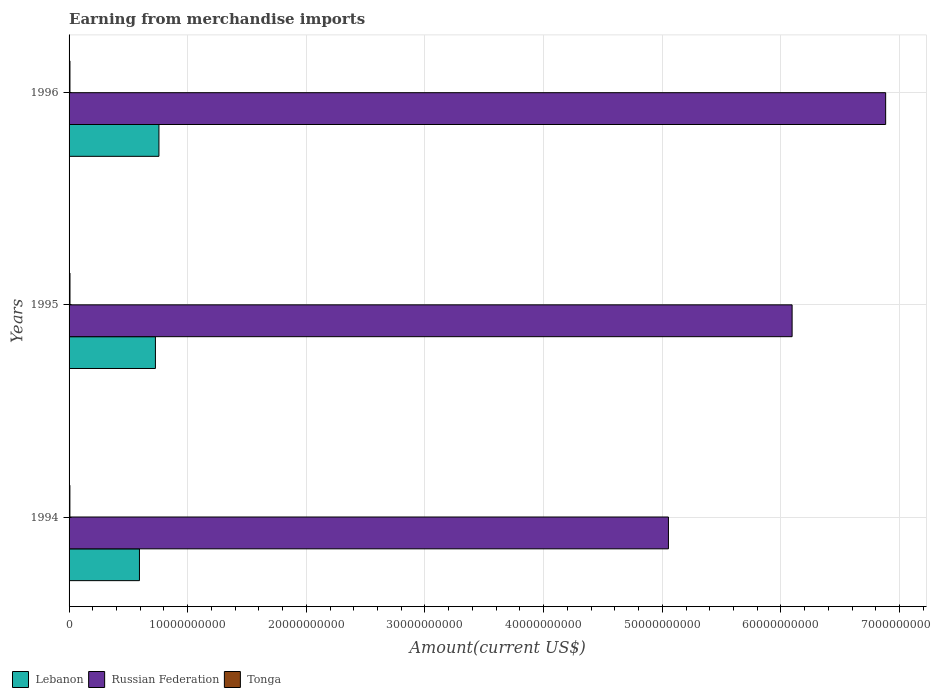How many different coloured bars are there?
Offer a very short reply. 3. Are the number of bars per tick equal to the number of legend labels?
Give a very brief answer. Yes. Are the number of bars on each tick of the Y-axis equal?
Provide a succinct answer. Yes. How many bars are there on the 3rd tick from the top?
Offer a terse response. 3. In how many cases, is the number of bars for a given year not equal to the number of legend labels?
Offer a terse response. 0. What is the amount earned from merchandise imports in Lebanon in 1995?
Offer a very short reply. 7.28e+09. Across all years, what is the maximum amount earned from merchandise imports in Lebanon?
Make the answer very short. 7.58e+09. Across all years, what is the minimum amount earned from merchandise imports in Tonga?
Your answer should be compact. 6.90e+07. In which year was the amount earned from merchandise imports in Tonga minimum?
Make the answer very short. 1994. What is the total amount earned from merchandise imports in Tonga in the graph?
Keep it short and to the point. 2.21e+08. What is the difference between the amount earned from merchandise imports in Lebanon in 1994 and that in 1996?
Provide a short and direct response. -1.64e+09. What is the difference between the amount earned from merchandise imports in Tonga in 1994 and the amount earned from merchandise imports in Lebanon in 1996?
Provide a short and direct response. -7.51e+09. What is the average amount earned from merchandise imports in Lebanon per year?
Offer a terse response. 6.93e+09. In the year 1996, what is the difference between the amount earned from merchandise imports in Russian Federation and amount earned from merchandise imports in Tonga?
Offer a terse response. 6.88e+1. In how many years, is the amount earned from merchandise imports in Russian Federation greater than 20000000000 US$?
Make the answer very short. 3. What is the ratio of the amount earned from merchandise imports in Russian Federation in 1994 to that in 1996?
Give a very brief answer. 0.73. Is the difference between the amount earned from merchandise imports in Russian Federation in 1994 and 1996 greater than the difference between the amount earned from merchandise imports in Tonga in 1994 and 1996?
Your answer should be very brief. No. What is the difference between the highest and the second highest amount earned from merchandise imports in Tonga?
Ensure brevity in your answer.  2.00e+06. What is the difference between the highest and the lowest amount earned from merchandise imports in Russian Federation?
Offer a terse response. 1.83e+1. In how many years, is the amount earned from merchandise imports in Tonga greater than the average amount earned from merchandise imports in Tonga taken over all years?
Keep it short and to the point. 2. What does the 2nd bar from the top in 1994 represents?
Offer a very short reply. Russian Federation. What does the 3rd bar from the bottom in 1995 represents?
Give a very brief answer. Tonga. How many bars are there?
Your answer should be very brief. 9. Does the graph contain grids?
Your answer should be compact. Yes. How many legend labels are there?
Give a very brief answer. 3. How are the legend labels stacked?
Your answer should be compact. Horizontal. What is the title of the graph?
Offer a terse response. Earning from merchandise imports. Does "Austria" appear as one of the legend labels in the graph?
Give a very brief answer. No. What is the label or title of the X-axis?
Your answer should be very brief. Amount(current US$). What is the label or title of the Y-axis?
Make the answer very short. Years. What is the Amount(current US$) of Lebanon in 1994?
Ensure brevity in your answer.  5.93e+09. What is the Amount(current US$) of Russian Federation in 1994?
Your response must be concise. 5.05e+1. What is the Amount(current US$) of Tonga in 1994?
Provide a short and direct response. 6.90e+07. What is the Amount(current US$) in Lebanon in 1995?
Give a very brief answer. 7.28e+09. What is the Amount(current US$) of Russian Federation in 1995?
Make the answer very short. 6.09e+1. What is the Amount(current US$) of Tonga in 1995?
Offer a terse response. 7.70e+07. What is the Amount(current US$) of Lebanon in 1996?
Provide a short and direct response. 7.58e+09. What is the Amount(current US$) in Russian Federation in 1996?
Your answer should be very brief. 6.88e+1. What is the Amount(current US$) in Tonga in 1996?
Provide a short and direct response. 7.50e+07. Across all years, what is the maximum Amount(current US$) of Lebanon?
Your answer should be compact. 7.58e+09. Across all years, what is the maximum Amount(current US$) in Russian Federation?
Make the answer very short. 6.88e+1. Across all years, what is the maximum Amount(current US$) of Tonga?
Your response must be concise. 7.70e+07. Across all years, what is the minimum Amount(current US$) in Lebanon?
Your response must be concise. 5.93e+09. Across all years, what is the minimum Amount(current US$) in Russian Federation?
Your response must be concise. 5.05e+1. Across all years, what is the minimum Amount(current US$) in Tonga?
Ensure brevity in your answer.  6.90e+07. What is the total Amount(current US$) in Lebanon in the graph?
Provide a succinct answer. 2.08e+1. What is the total Amount(current US$) in Russian Federation in the graph?
Ensure brevity in your answer.  1.80e+11. What is the total Amount(current US$) of Tonga in the graph?
Give a very brief answer. 2.21e+08. What is the difference between the Amount(current US$) in Lebanon in 1994 and that in 1995?
Make the answer very short. -1.34e+09. What is the difference between the Amount(current US$) of Russian Federation in 1994 and that in 1995?
Offer a terse response. -1.04e+1. What is the difference between the Amount(current US$) of Tonga in 1994 and that in 1995?
Your answer should be compact. -8.00e+06. What is the difference between the Amount(current US$) in Lebanon in 1994 and that in 1996?
Provide a short and direct response. -1.64e+09. What is the difference between the Amount(current US$) in Russian Federation in 1994 and that in 1996?
Keep it short and to the point. -1.83e+1. What is the difference between the Amount(current US$) of Tonga in 1994 and that in 1996?
Provide a short and direct response. -6.00e+06. What is the difference between the Amount(current US$) of Lebanon in 1995 and that in 1996?
Give a very brief answer. -2.97e+08. What is the difference between the Amount(current US$) of Russian Federation in 1995 and that in 1996?
Offer a very short reply. -7.88e+09. What is the difference between the Amount(current US$) in Lebanon in 1994 and the Amount(current US$) in Russian Federation in 1995?
Your answer should be very brief. -5.50e+1. What is the difference between the Amount(current US$) of Lebanon in 1994 and the Amount(current US$) of Tonga in 1995?
Make the answer very short. 5.86e+09. What is the difference between the Amount(current US$) in Russian Federation in 1994 and the Amount(current US$) in Tonga in 1995?
Provide a succinct answer. 5.04e+1. What is the difference between the Amount(current US$) of Lebanon in 1994 and the Amount(current US$) of Russian Federation in 1996?
Keep it short and to the point. -6.29e+1. What is the difference between the Amount(current US$) of Lebanon in 1994 and the Amount(current US$) of Tonga in 1996?
Provide a short and direct response. 5.86e+09. What is the difference between the Amount(current US$) of Russian Federation in 1994 and the Amount(current US$) of Tonga in 1996?
Make the answer very short. 5.04e+1. What is the difference between the Amount(current US$) in Lebanon in 1995 and the Amount(current US$) in Russian Federation in 1996?
Give a very brief answer. -6.16e+1. What is the difference between the Amount(current US$) in Lebanon in 1995 and the Amount(current US$) in Tonga in 1996?
Your answer should be compact. 7.20e+09. What is the difference between the Amount(current US$) in Russian Federation in 1995 and the Amount(current US$) in Tonga in 1996?
Your answer should be very brief. 6.09e+1. What is the average Amount(current US$) of Lebanon per year?
Ensure brevity in your answer.  6.93e+09. What is the average Amount(current US$) of Russian Federation per year?
Your response must be concise. 6.01e+1. What is the average Amount(current US$) in Tonga per year?
Provide a short and direct response. 7.37e+07. In the year 1994, what is the difference between the Amount(current US$) in Lebanon and Amount(current US$) in Russian Federation?
Make the answer very short. -4.46e+1. In the year 1994, what is the difference between the Amount(current US$) in Lebanon and Amount(current US$) in Tonga?
Offer a very short reply. 5.86e+09. In the year 1994, what is the difference between the Amount(current US$) of Russian Federation and Amount(current US$) of Tonga?
Your answer should be compact. 5.05e+1. In the year 1995, what is the difference between the Amount(current US$) in Lebanon and Amount(current US$) in Russian Federation?
Offer a terse response. -5.37e+1. In the year 1995, what is the difference between the Amount(current US$) of Lebanon and Amount(current US$) of Tonga?
Your response must be concise. 7.20e+09. In the year 1995, what is the difference between the Amount(current US$) in Russian Federation and Amount(current US$) in Tonga?
Your response must be concise. 6.09e+1. In the year 1996, what is the difference between the Amount(current US$) of Lebanon and Amount(current US$) of Russian Federation?
Your response must be concise. -6.13e+1. In the year 1996, what is the difference between the Amount(current US$) in Lebanon and Amount(current US$) in Tonga?
Your answer should be very brief. 7.50e+09. In the year 1996, what is the difference between the Amount(current US$) of Russian Federation and Amount(current US$) of Tonga?
Ensure brevity in your answer.  6.88e+1. What is the ratio of the Amount(current US$) of Lebanon in 1994 to that in 1995?
Provide a succinct answer. 0.82. What is the ratio of the Amount(current US$) of Russian Federation in 1994 to that in 1995?
Your answer should be very brief. 0.83. What is the ratio of the Amount(current US$) in Tonga in 1994 to that in 1995?
Keep it short and to the point. 0.9. What is the ratio of the Amount(current US$) in Lebanon in 1994 to that in 1996?
Your answer should be very brief. 0.78. What is the ratio of the Amount(current US$) in Russian Federation in 1994 to that in 1996?
Offer a very short reply. 0.73. What is the ratio of the Amount(current US$) of Tonga in 1994 to that in 1996?
Your response must be concise. 0.92. What is the ratio of the Amount(current US$) of Lebanon in 1995 to that in 1996?
Ensure brevity in your answer.  0.96. What is the ratio of the Amount(current US$) of Russian Federation in 1995 to that in 1996?
Give a very brief answer. 0.89. What is the ratio of the Amount(current US$) of Tonga in 1995 to that in 1996?
Make the answer very short. 1.03. What is the difference between the highest and the second highest Amount(current US$) of Lebanon?
Your answer should be compact. 2.97e+08. What is the difference between the highest and the second highest Amount(current US$) in Russian Federation?
Give a very brief answer. 7.88e+09. What is the difference between the highest and the lowest Amount(current US$) in Lebanon?
Make the answer very short. 1.64e+09. What is the difference between the highest and the lowest Amount(current US$) of Russian Federation?
Provide a succinct answer. 1.83e+1. What is the difference between the highest and the lowest Amount(current US$) in Tonga?
Provide a short and direct response. 8.00e+06. 